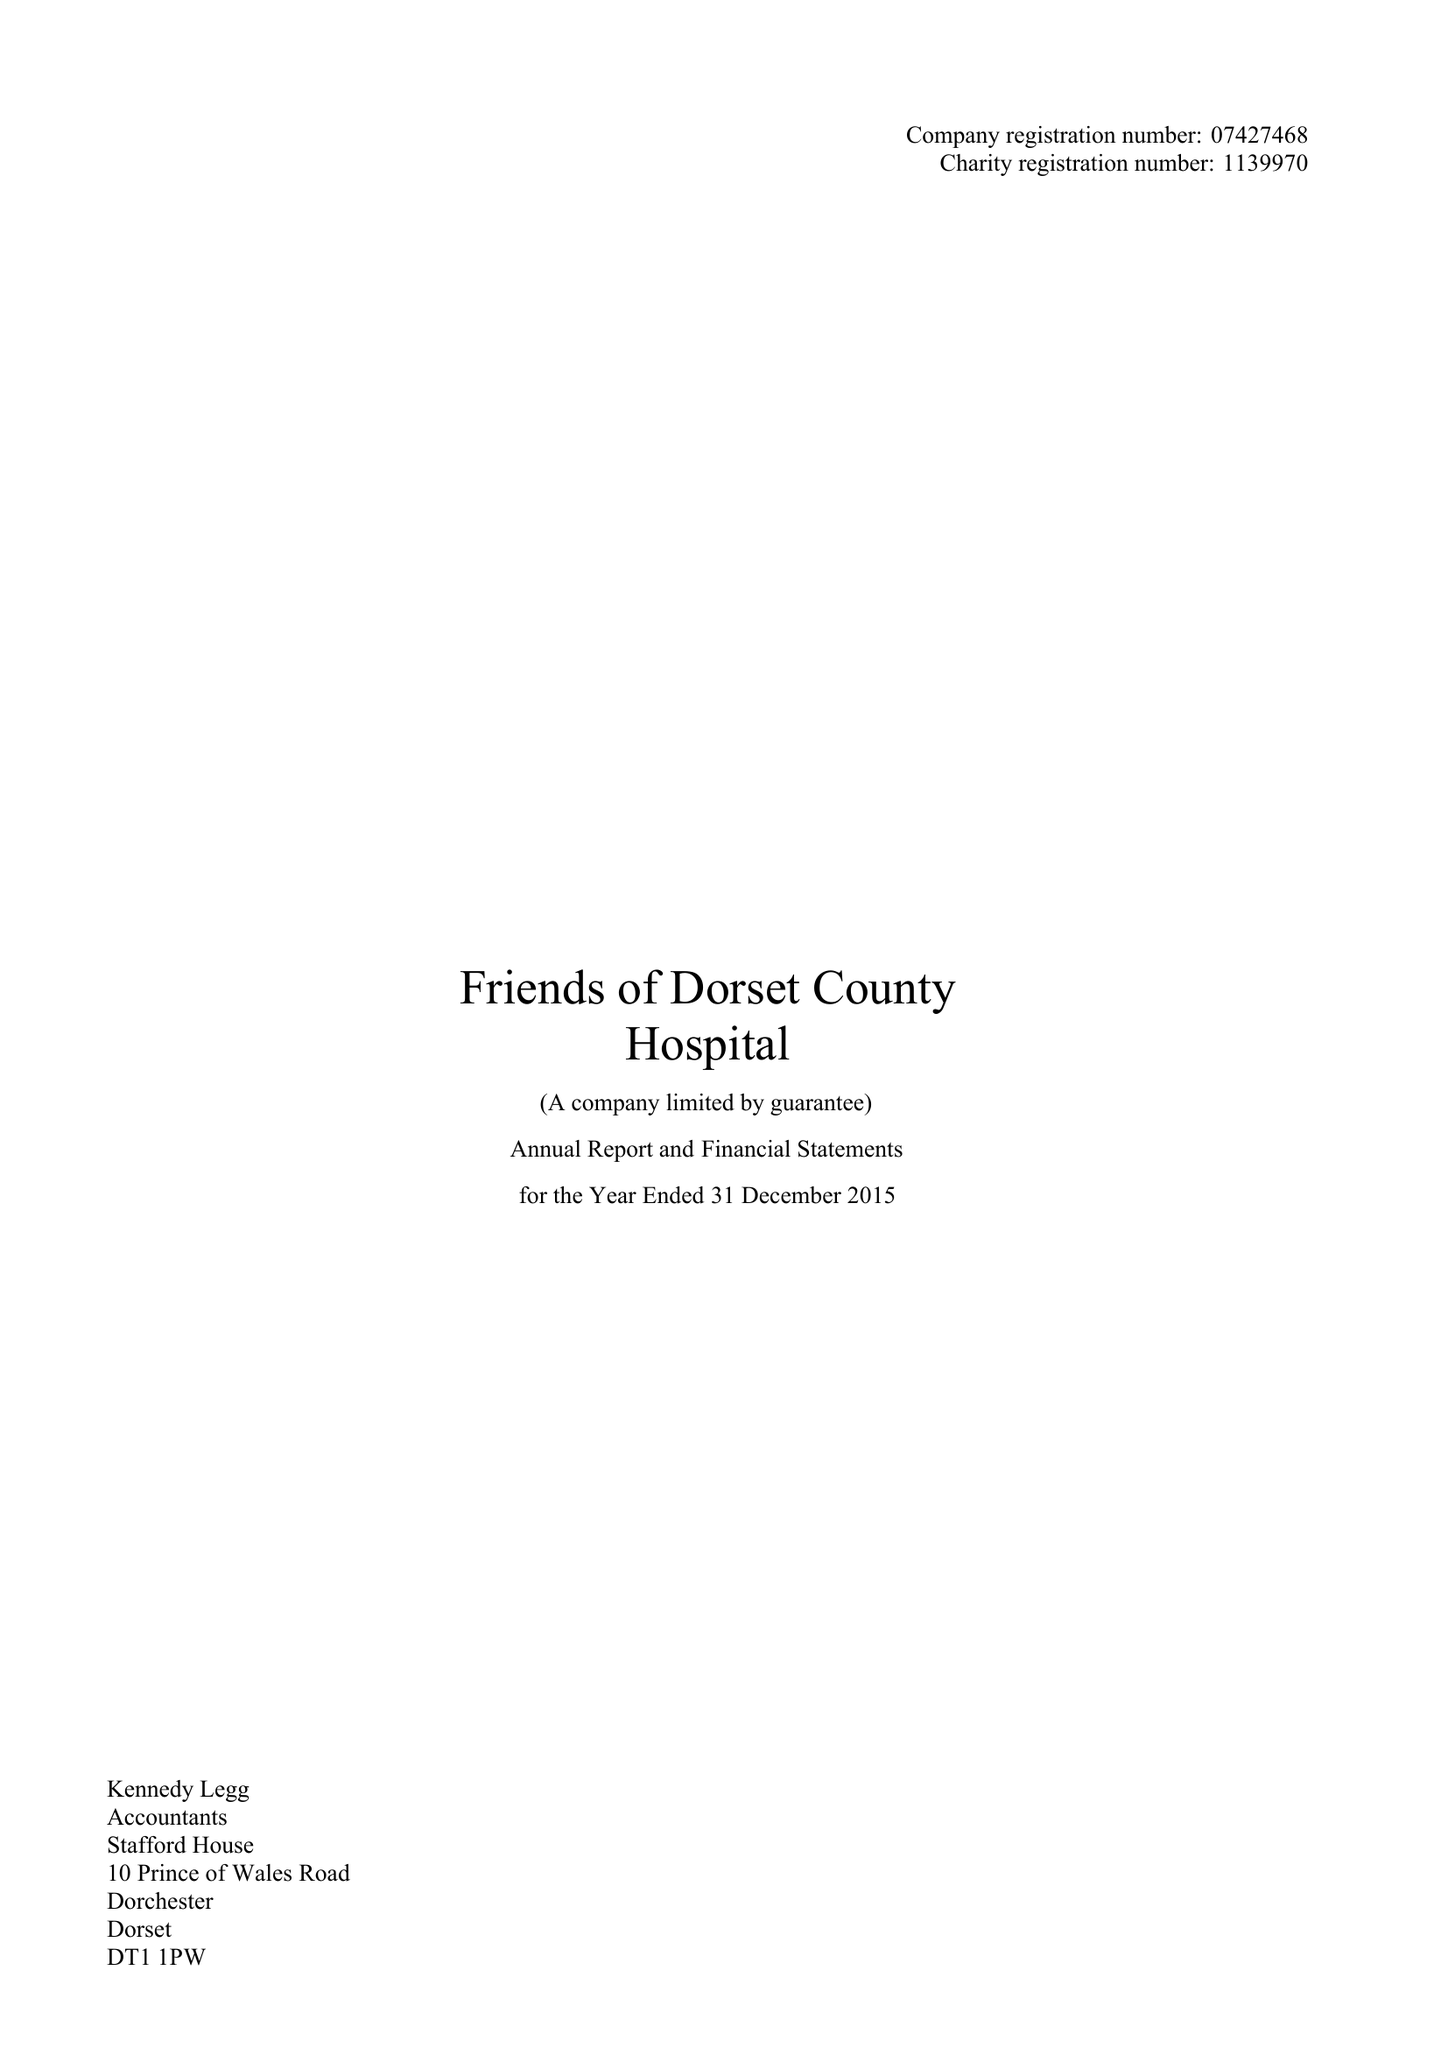What is the value for the charity_number?
Answer the question using a single word or phrase. 1139970 